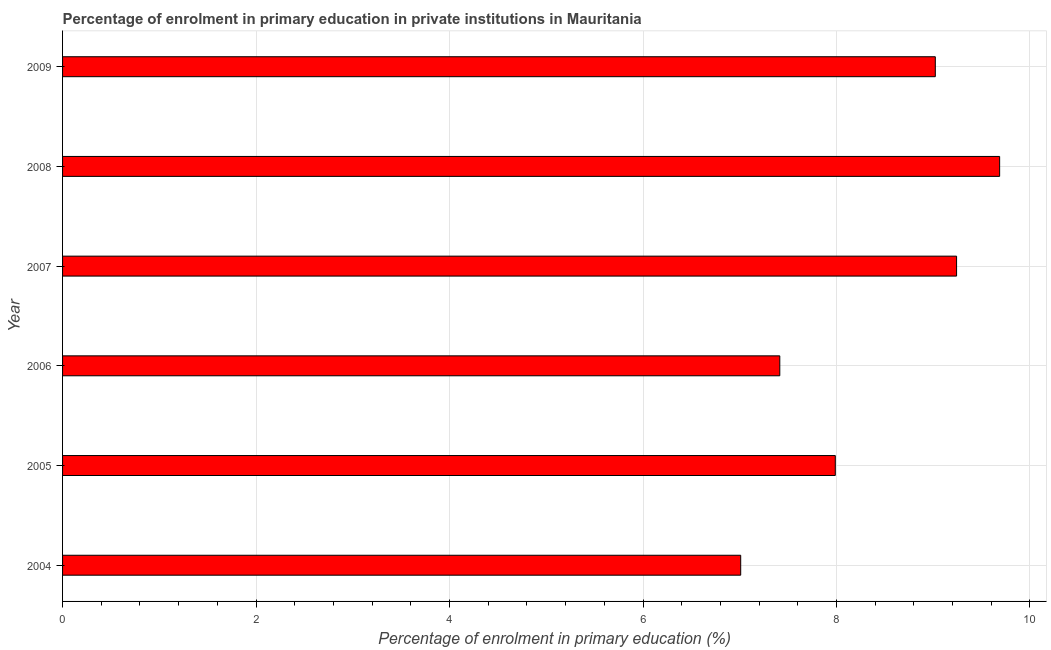Does the graph contain any zero values?
Provide a succinct answer. No. What is the title of the graph?
Offer a terse response. Percentage of enrolment in primary education in private institutions in Mauritania. What is the label or title of the X-axis?
Your answer should be very brief. Percentage of enrolment in primary education (%). What is the label or title of the Y-axis?
Provide a short and direct response. Year. What is the enrolment percentage in primary education in 2007?
Keep it short and to the point. 9.24. Across all years, what is the maximum enrolment percentage in primary education?
Your response must be concise. 9.69. Across all years, what is the minimum enrolment percentage in primary education?
Keep it short and to the point. 7.01. In which year was the enrolment percentage in primary education maximum?
Offer a very short reply. 2008. What is the sum of the enrolment percentage in primary education?
Keep it short and to the point. 50.36. What is the difference between the enrolment percentage in primary education in 2004 and 2007?
Make the answer very short. -2.23. What is the average enrolment percentage in primary education per year?
Your response must be concise. 8.39. What is the median enrolment percentage in primary education?
Make the answer very short. 8.5. Do a majority of the years between 2008 and 2007 (inclusive) have enrolment percentage in primary education greater than 4 %?
Ensure brevity in your answer.  No. What is the ratio of the enrolment percentage in primary education in 2006 to that in 2008?
Keep it short and to the point. 0.77. What is the difference between the highest and the second highest enrolment percentage in primary education?
Make the answer very short. 0.45. Is the sum of the enrolment percentage in primary education in 2004 and 2009 greater than the maximum enrolment percentage in primary education across all years?
Offer a very short reply. Yes. What is the difference between the highest and the lowest enrolment percentage in primary education?
Offer a very short reply. 2.68. What is the difference between two consecutive major ticks on the X-axis?
Offer a very short reply. 2. What is the Percentage of enrolment in primary education (%) of 2004?
Ensure brevity in your answer.  7.01. What is the Percentage of enrolment in primary education (%) of 2005?
Your answer should be compact. 7.99. What is the Percentage of enrolment in primary education (%) in 2006?
Offer a terse response. 7.41. What is the Percentage of enrolment in primary education (%) in 2007?
Ensure brevity in your answer.  9.24. What is the Percentage of enrolment in primary education (%) of 2008?
Your answer should be very brief. 9.69. What is the Percentage of enrolment in primary education (%) in 2009?
Offer a terse response. 9.02. What is the difference between the Percentage of enrolment in primary education (%) in 2004 and 2005?
Ensure brevity in your answer.  -0.98. What is the difference between the Percentage of enrolment in primary education (%) in 2004 and 2006?
Keep it short and to the point. -0.4. What is the difference between the Percentage of enrolment in primary education (%) in 2004 and 2007?
Offer a terse response. -2.23. What is the difference between the Percentage of enrolment in primary education (%) in 2004 and 2008?
Ensure brevity in your answer.  -2.68. What is the difference between the Percentage of enrolment in primary education (%) in 2004 and 2009?
Offer a terse response. -2.01. What is the difference between the Percentage of enrolment in primary education (%) in 2005 and 2006?
Keep it short and to the point. 0.57. What is the difference between the Percentage of enrolment in primary education (%) in 2005 and 2007?
Keep it short and to the point. -1.25. What is the difference between the Percentage of enrolment in primary education (%) in 2005 and 2008?
Provide a short and direct response. -1.7. What is the difference between the Percentage of enrolment in primary education (%) in 2005 and 2009?
Offer a very short reply. -1.03. What is the difference between the Percentage of enrolment in primary education (%) in 2006 and 2007?
Offer a very short reply. -1.83. What is the difference between the Percentage of enrolment in primary education (%) in 2006 and 2008?
Give a very brief answer. -2.27. What is the difference between the Percentage of enrolment in primary education (%) in 2006 and 2009?
Offer a terse response. -1.61. What is the difference between the Percentage of enrolment in primary education (%) in 2007 and 2008?
Ensure brevity in your answer.  -0.45. What is the difference between the Percentage of enrolment in primary education (%) in 2007 and 2009?
Give a very brief answer. 0.22. What is the difference between the Percentage of enrolment in primary education (%) in 2008 and 2009?
Give a very brief answer. 0.66. What is the ratio of the Percentage of enrolment in primary education (%) in 2004 to that in 2005?
Give a very brief answer. 0.88. What is the ratio of the Percentage of enrolment in primary education (%) in 2004 to that in 2006?
Provide a short and direct response. 0.95. What is the ratio of the Percentage of enrolment in primary education (%) in 2004 to that in 2007?
Your answer should be compact. 0.76. What is the ratio of the Percentage of enrolment in primary education (%) in 2004 to that in 2008?
Make the answer very short. 0.72. What is the ratio of the Percentage of enrolment in primary education (%) in 2004 to that in 2009?
Make the answer very short. 0.78. What is the ratio of the Percentage of enrolment in primary education (%) in 2005 to that in 2006?
Offer a terse response. 1.08. What is the ratio of the Percentage of enrolment in primary education (%) in 2005 to that in 2007?
Your answer should be very brief. 0.86. What is the ratio of the Percentage of enrolment in primary education (%) in 2005 to that in 2008?
Provide a short and direct response. 0.82. What is the ratio of the Percentage of enrolment in primary education (%) in 2005 to that in 2009?
Keep it short and to the point. 0.89. What is the ratio of the Percentage of enrolment in primary education (%) in 2006 to that in 2007?
Keep it short and to the point. 0.8. What is the ratio of the Percentage of enrolment in primary education (%) in 2006 to that in 2008?
Provide a succinct answer. 0.77. What is the ratio of the Percentage of enrolment in primary education (%) in 2006 to that in 2009?
Your response must be concise. 0.82. What is the ratio of the Percentage of enrolment in primary education (%) in 2007 to that in 2008?
Provide a succinct answer. 0.95. What is the ratio of the Percentage of enrolment in primary education (%) in 2008 to that in 2009?
Ensure brevity in your answer.  1.07. 